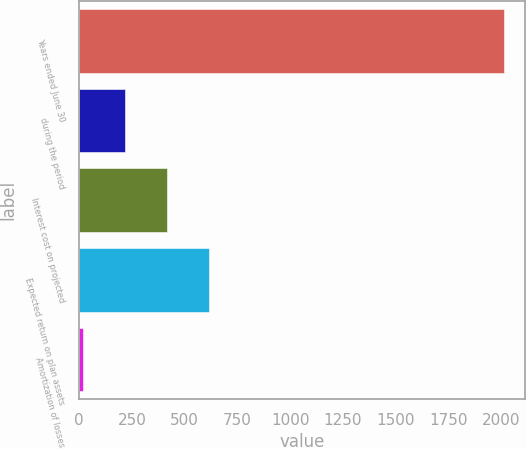Convert chart. <chart><loc_0><loc_0><loc_500><loc_500><bar_chart><fcel>Years ended June 30<fcel>during the period<fcel>Interest cost on projected<fcel>Expected return on plan assets<fcel>Amortization of losses<nl><fcel>2011<fcel>219.19<fcel>418.28<fcel>617.37<fcel>20.1<nl></chart> 